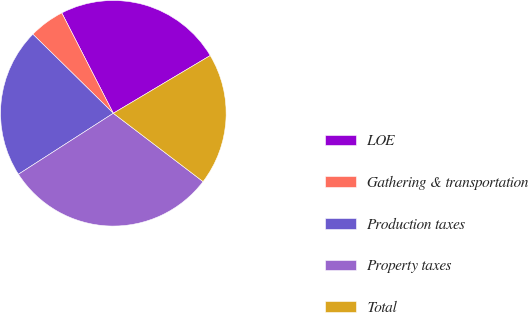Convert chart to OTSL. <chart><loc_0><loc_0><loc_500><loc_500><pie_chart><fcel>LOE<fcel>Gathering & transportation<fcel>Production taxes<fcel>Property taxes<fcel>Total<nl><fcel>24.0%<fcel>5.09%<fcel>21.45%<fcel>30.55%<fcel>18.91%<nl></chart> 